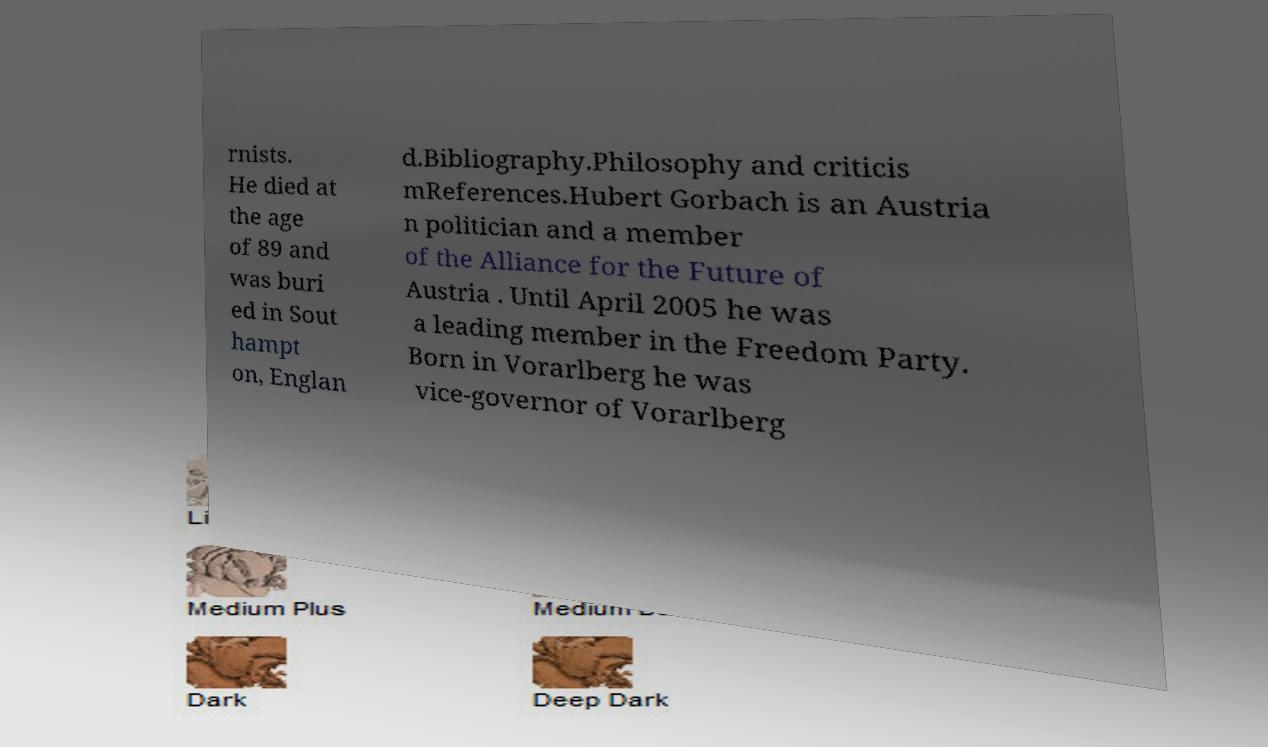Can you read and provide the text displayed in the image?This photo seems to have some interesting text. Can you extract and type it out for me? rnists. He died at the age of 89 and was buri ed in Sout hampt on, Englan d.Bibliography.Philosophy and criticis mReferences.Hubert Gorbach is an Austria n politician and a member of the Alliance for the Future of Austria . Until April 2005 he was a leading member in the Freedom Party. Born in Vorarlberg he was vice-governor of Vorarlberg 